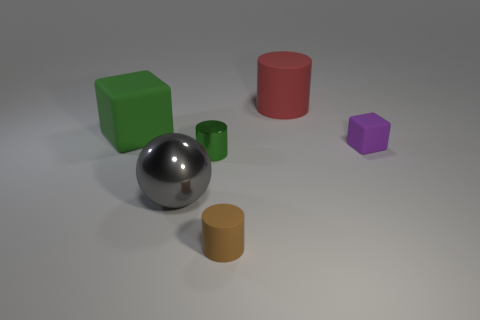This setting feels quite artificial. Could it be a simulation or a rendering? Based on the uniform lighting and absence of complex textures, the image does appear to be a computer generated rendering rather than a photograph of physical objects. 